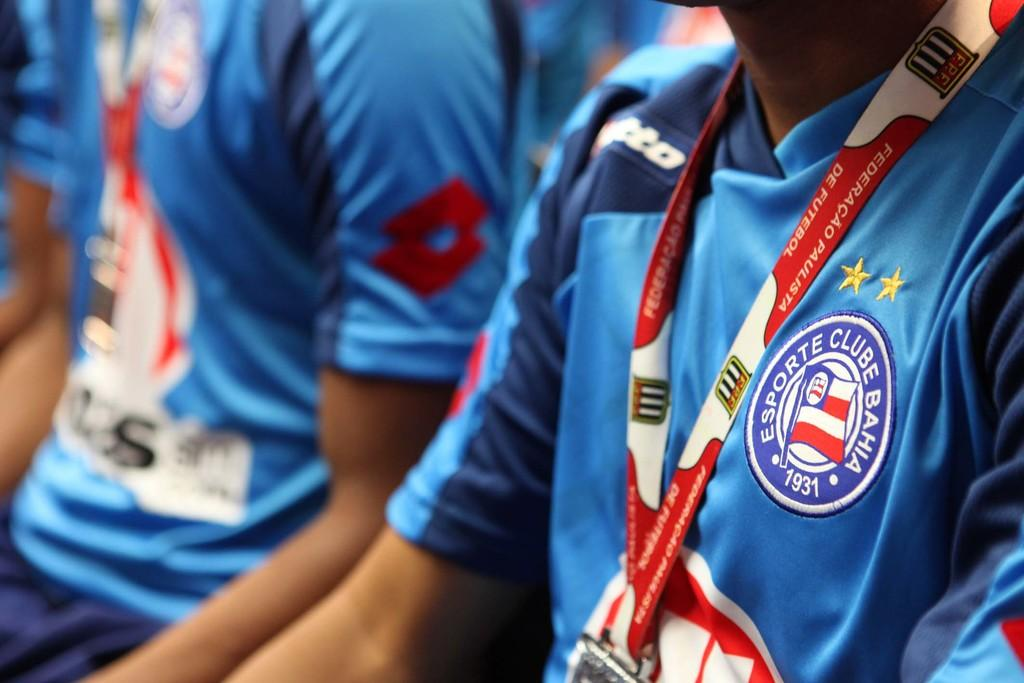<image>
Provide a brief description of the given image. A pair of athletes wearing blue uniforms representing Esporte Club Bahia. 